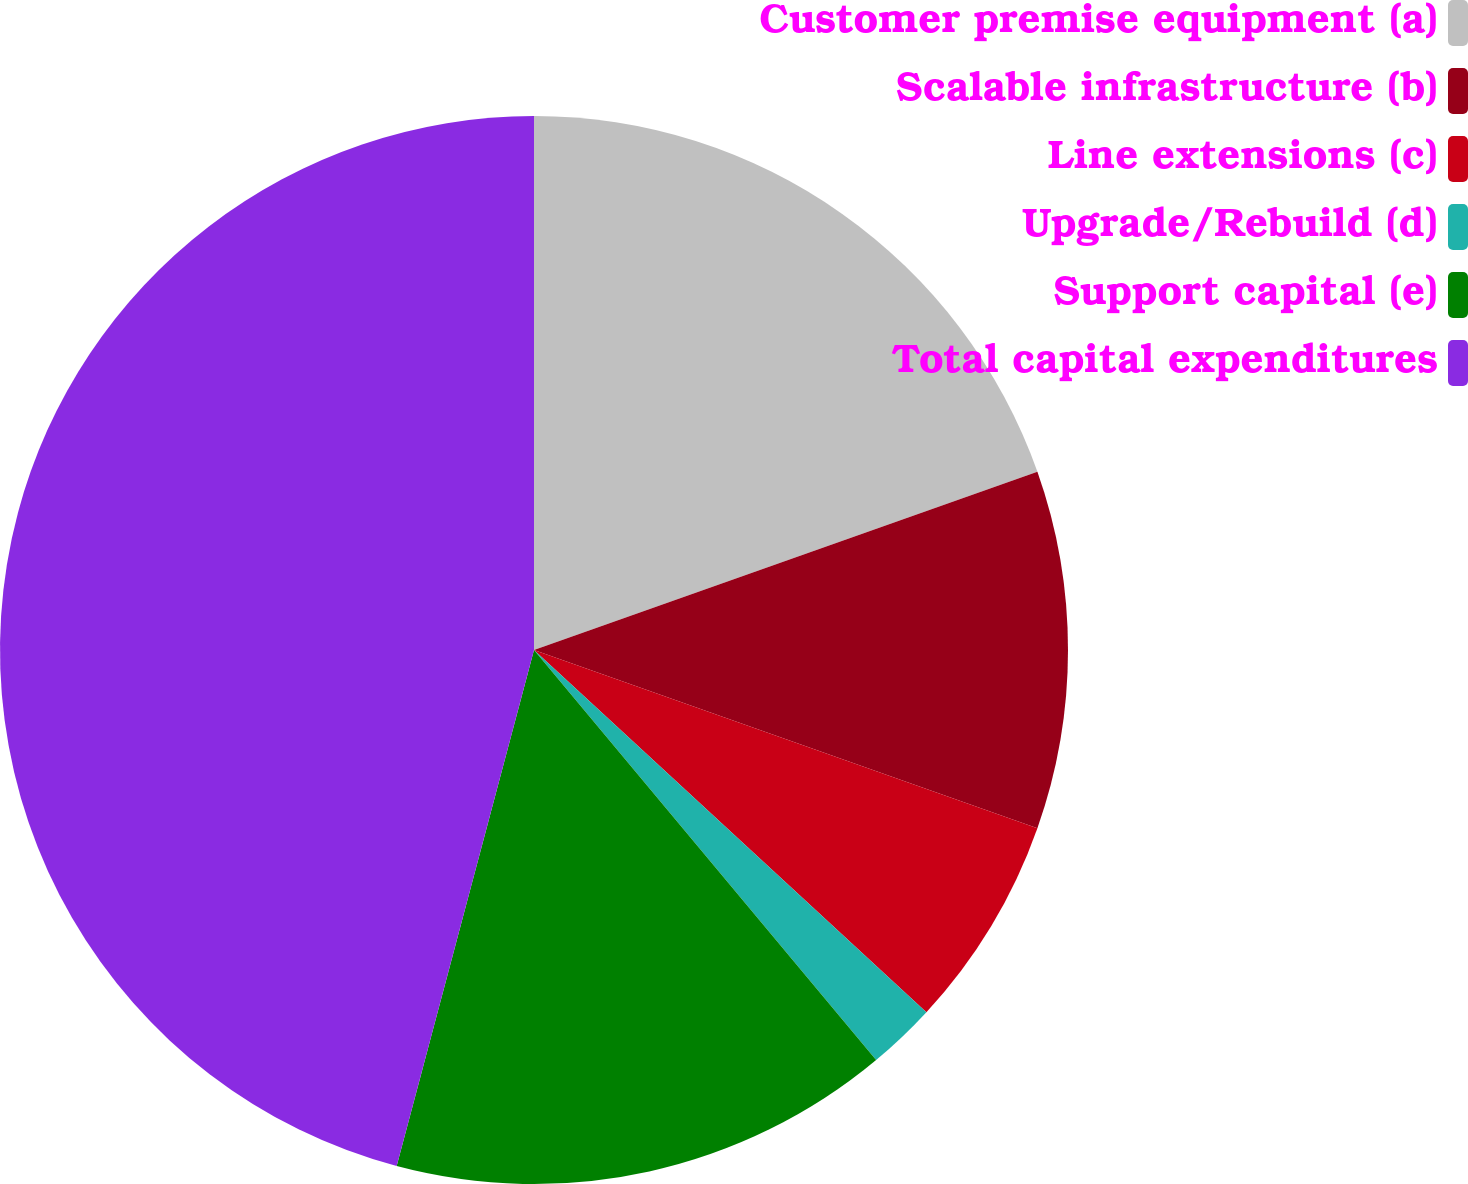<chart> <loc_0><loc_0><loc_500><loc_500><pie_chart><fcel>Customer premise equipment (a)<fcel>Scalable infrastructure (b)<fcel>Line extensions (c)<fcel>Upgrade/Rebuild (d)<fcel>Support capital (e)<fcel>Total capital expenditures<nl><fcel>19.59%<fcel>10.83%<fcel>6.45%<fcel>2.07%<fcel>15.21%<fcel>45.87%<nl></chart> 